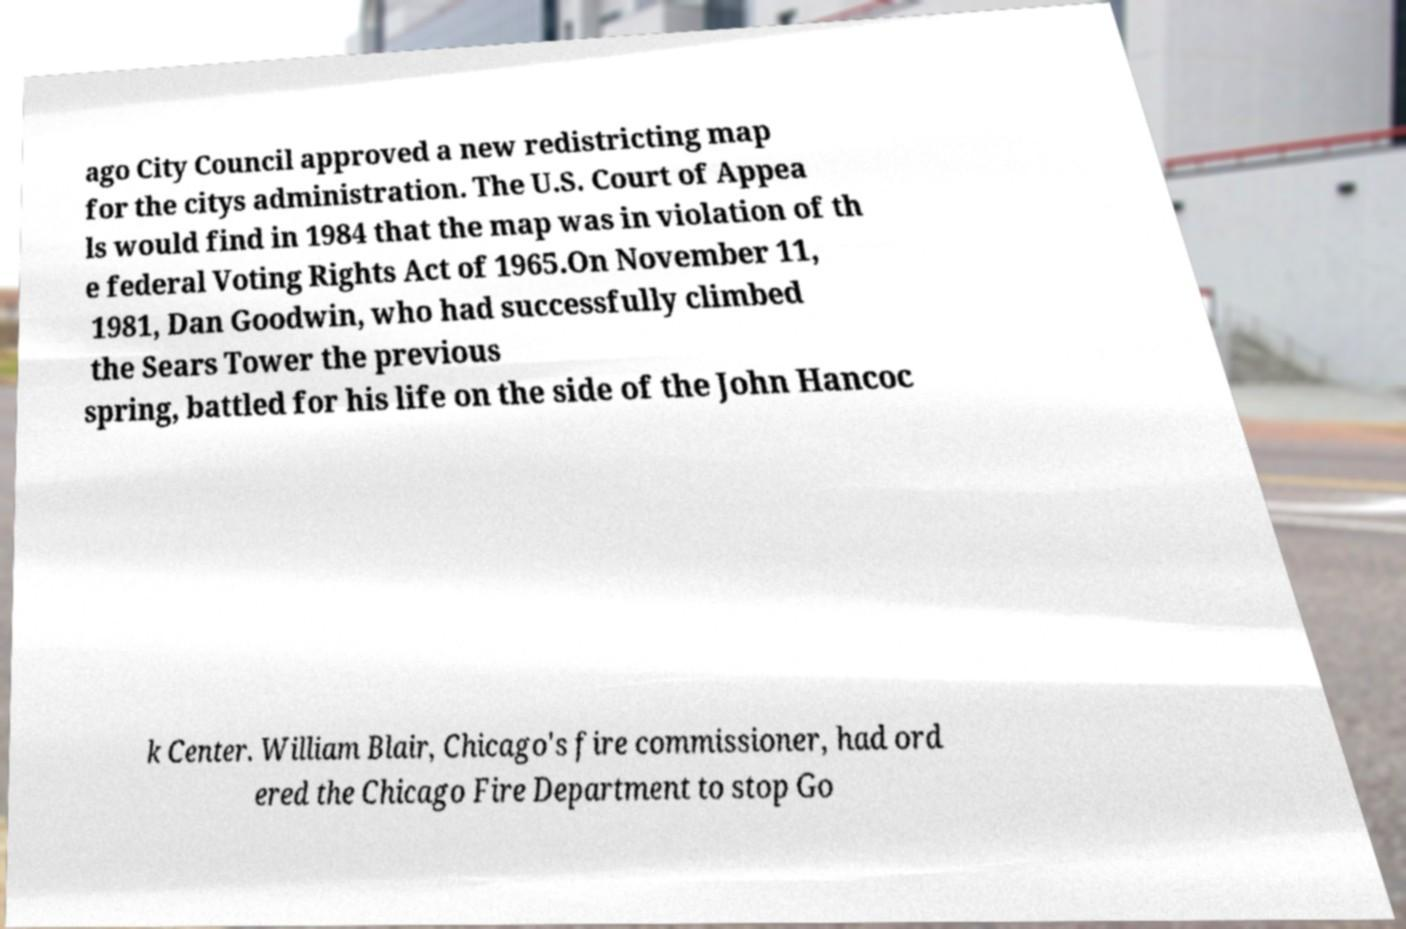For documentation purposes, I need the text within this image transcribed. Could you provide that? ago City Council approved a new redistricting map for the citys administration. The U.S. Court of Appea ls would find in 1984 that the map was in violation of th e federal Voting Rights Act of 1965.On November 11, 1981, Dan Goodwin, who had successfully climbed the Sears Tower the previous spring, battled for his life on the side of the John Hancoc k Center. William Blair, Chicago's fire commissioner, had ord ered the Chicago Fire Department to stop Go 